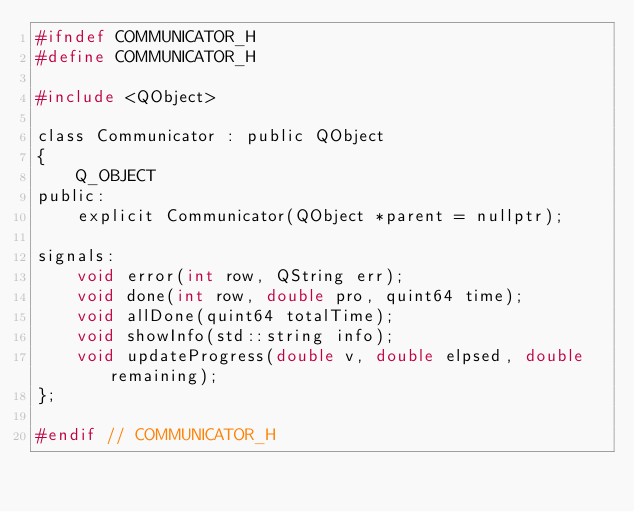Convert code to text. <code><loc_0><loc_0><loc_500><loc_500><_C_>#ifndef COMMUNICATOR_H
#define COMMUNICATOR_H

#include <QObject>

class Communicator : public QObject
{
    Q_OBJECT
public:
    explicit Communicator(QObject *parent = nullptr);

signals:
    void error(int row, QString err);
    void done(int row, double pro, quint64 time);
    void allDone(quint64 totalTime);
    void showInfo(std::string info);
    void updateProgress(double v, double elpsed, double remaining);
};

#endif // COMMUNICATOR_H
</code> 